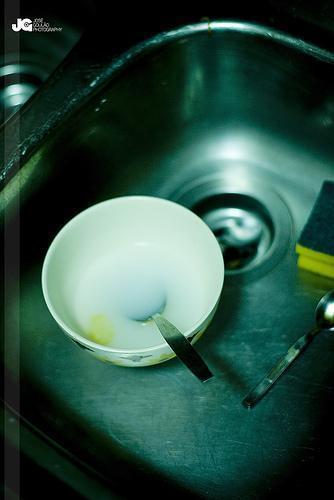How many sheep are there?
Give a very brief answer. 0. 